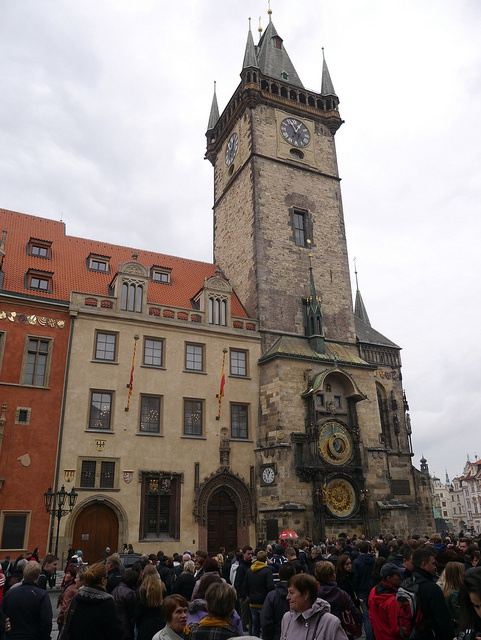Describe the objects in this image and their specific colors. I can see people in lavender, black, gray, and maroon tones, people in lavender, black, maroon, and gray tones, people in lavender, black, gray, and maroon tones, people in lavender, black, gray, and maroon tones, and people in lavender, black, maroon, and brown tones in this image. 